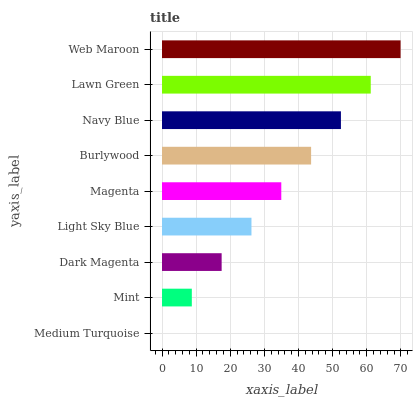Is Medium Turquoise the minimum?
Answer yes or no. Yes. Is Web Maroon the maximum?
Answer yes or no. Yes. Is Mint the minimum?
Answer yes or no. No. Is Mint the maximum?
Answer yes or no. No. Is Mint greater than Medium Turquoise?
Answer yes or no. Yes. Is Medium Turquoise less than Mint?
Answer yes or no. Yes. Is Medium Turquoise greater than Mint?
Answer yes or no. No. Is Mint less than Medium Turquoise?
Answer yes or no. No. Is Magenta the high median?
Answer yes or no. Yes. Is Magenta the low median?
Answer yes or no. Yes. Is Lawn Green the high median?
Answer yes or no. No. Is Medium Turquoise the low median?
Answer yes or no. No. 